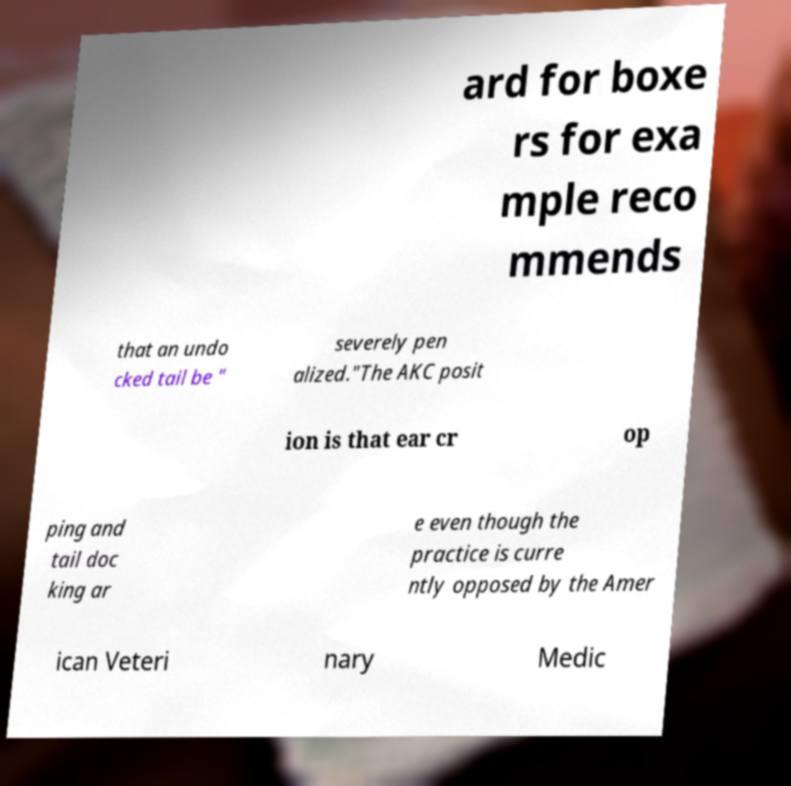For documentation purposes, I need the text within this image transcribed. Could you provide that? ard for boxe rs for exa mple reco mmends that an undo cked tail be " severely pen alized."The AKC posit ion is that ear cr op ping and tail doc king ar e even though the practice is curre ntly opposed by the Amer ican Veteri nary Medic 